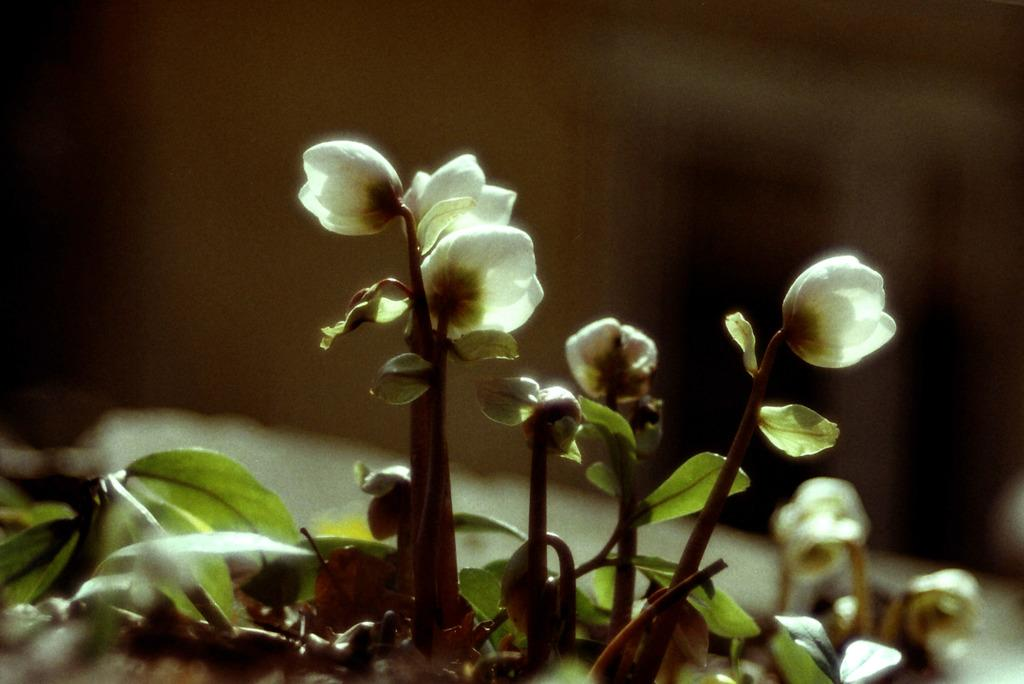What types of vegetation are present at the bottom of the image? There are plants and flowers at the bottom of the image. Can you describe the background of the image? The background of the image is blurry. What type of steel is visible in the image? There is no steel present in the image. How does pollution affect the plants and flowers in the image? There is no information about pollution in the image, so we cannot determine its effect on the plants and flowers. 